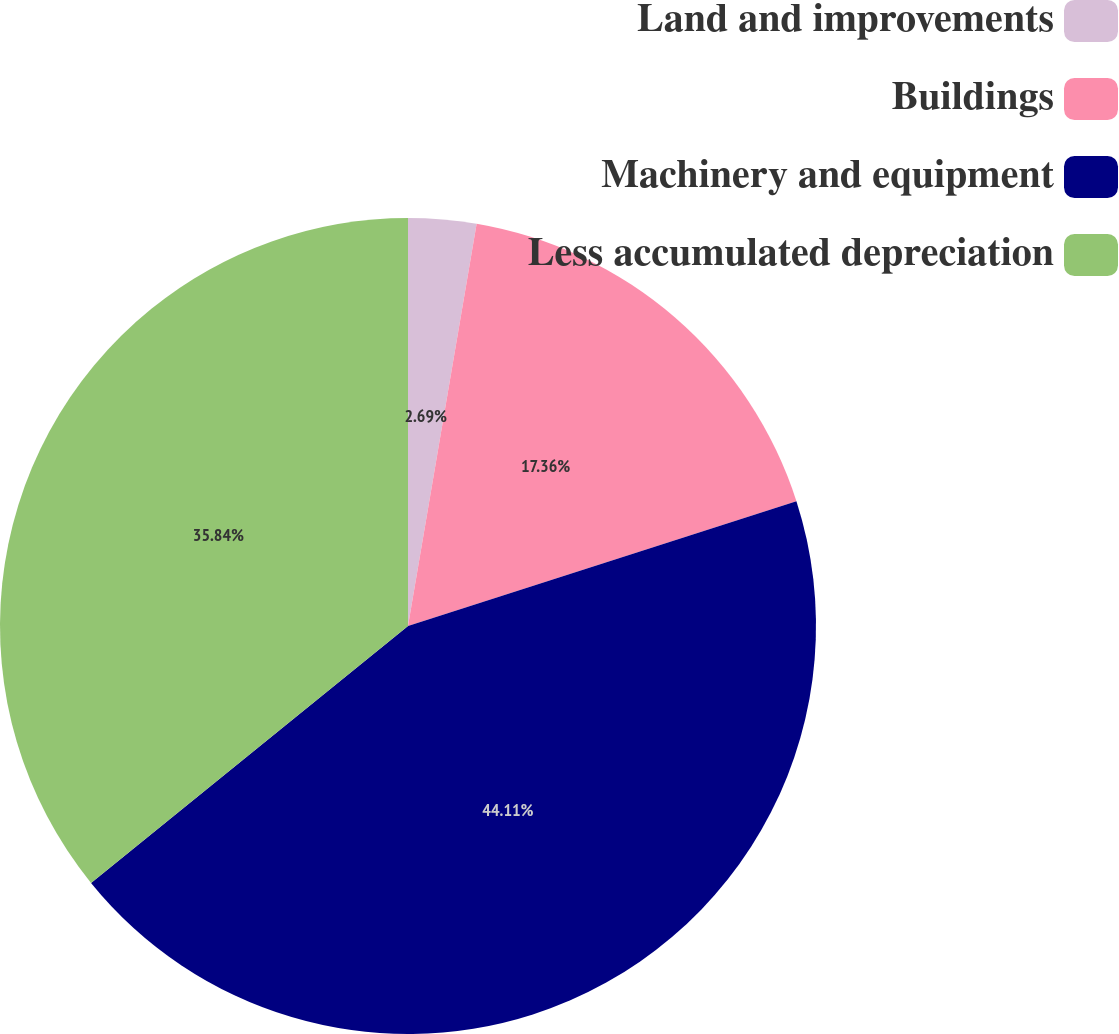Convert chart. <chart><loc_0><loc_0><loc_500><loc_500><pie_chart><fcel>Land and improvements<fcel>Buildings<fcel>Machinery and equipment<fcel>Less accumulated depreciation<nl><fcel>2.69%<fcel>17.36%<fcel>44.11%<fcel>35.84%<nl></chart> 